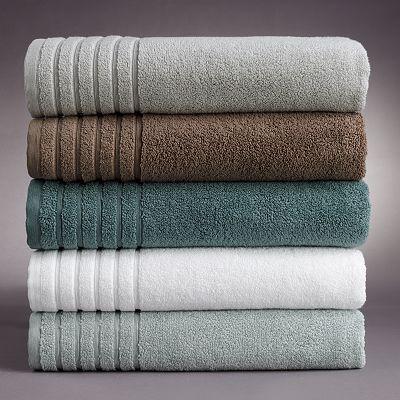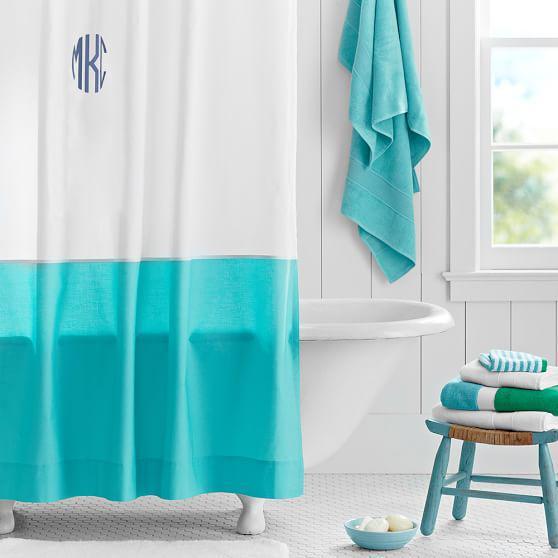The first image is the image on the left, the second image is the image on the right. Assess this claim about the two images: "An image features a room with solid-white walls, and a shower curtain featuring a turquoise lower half around an all-white tub.". Correct or not? Answer yes or no. Yes. The first image is the image on the left, the second image is the image on the right. For the images shown, is this caption "At least one bathroom has a stepstool." true? Answer yes or no. Yes. 